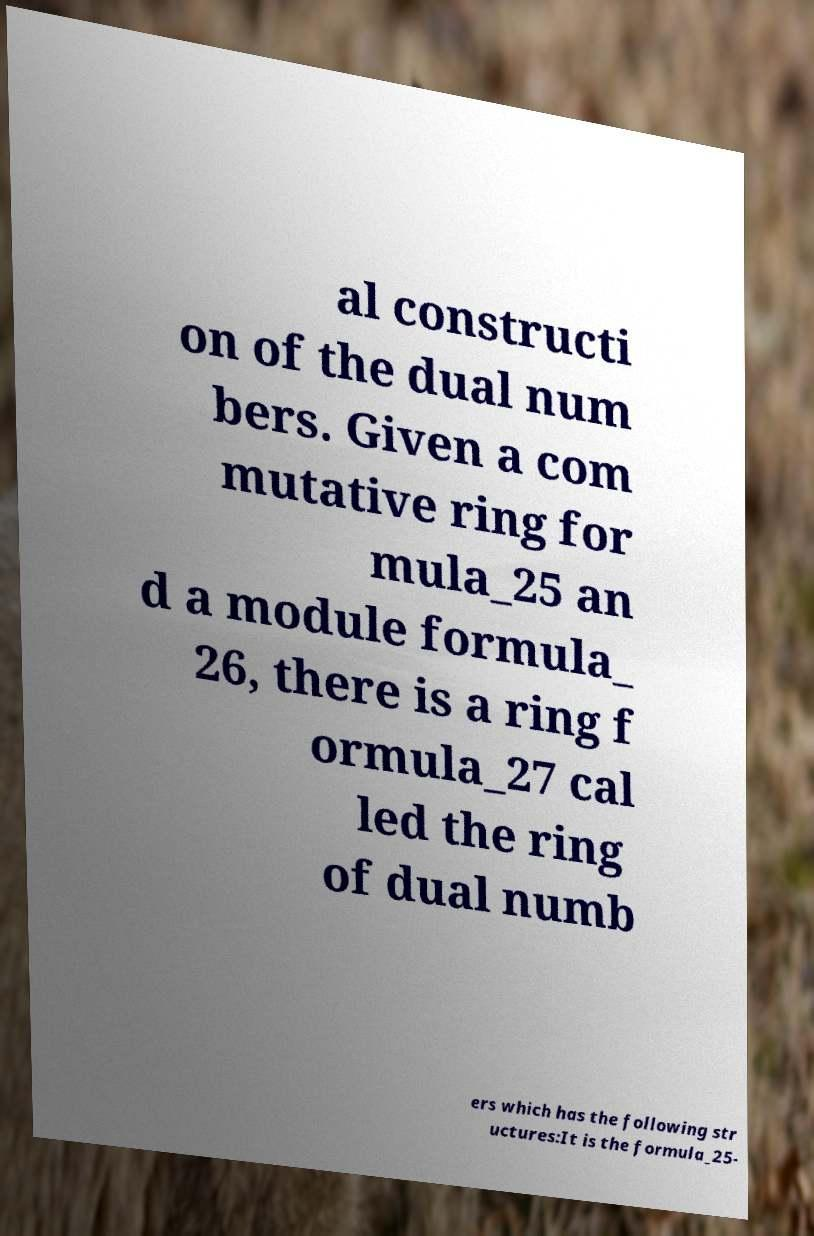Could you assist in decoding the text presented in this image and type it out clearly? al constructi on of the dual num bers. Given a com mutative ring for mula_25 an d a module formula_ 26, there is a ring f ormula_27 cal led the ring of dual numb ers which has the following str uctures:It is the formula_25- 